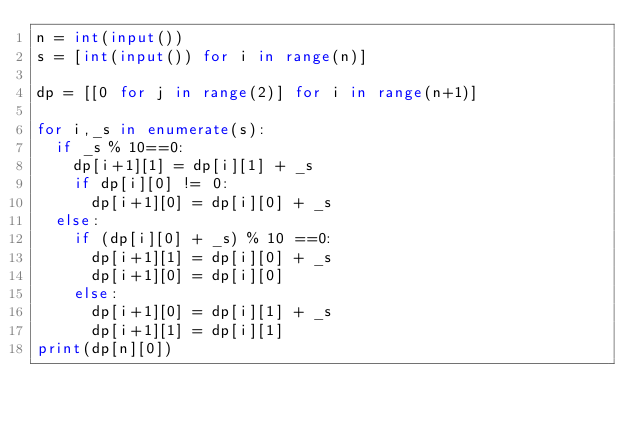Convert code to text. <code><loc_0><loc_0><loc_500><loc_500><_Python_>n = int(input())
s = [int(input()) for i in range(n)]

dp = [[0 for j in range(2)] for i in range(n+1)]

for i,_s in enumerate(s):
  if _s % 10==0:
    dp[i+1][1] = dp[i][1] + _s
    if dp[i][0] != 0:
      dp[i+1][0] = dp[i][0] + _s
  else:
    if (dp[i][0] + _s) % 10 ==0:
      dp[i+1][1] = dp[i][0] + _s
      dp[i+1][0] = dp[i][0]
    else:
      dp[i+1][0] = dp[i][1] + _s
      dp[i+1][1] = dp[i][1]
print(dp[n][0])</code> 